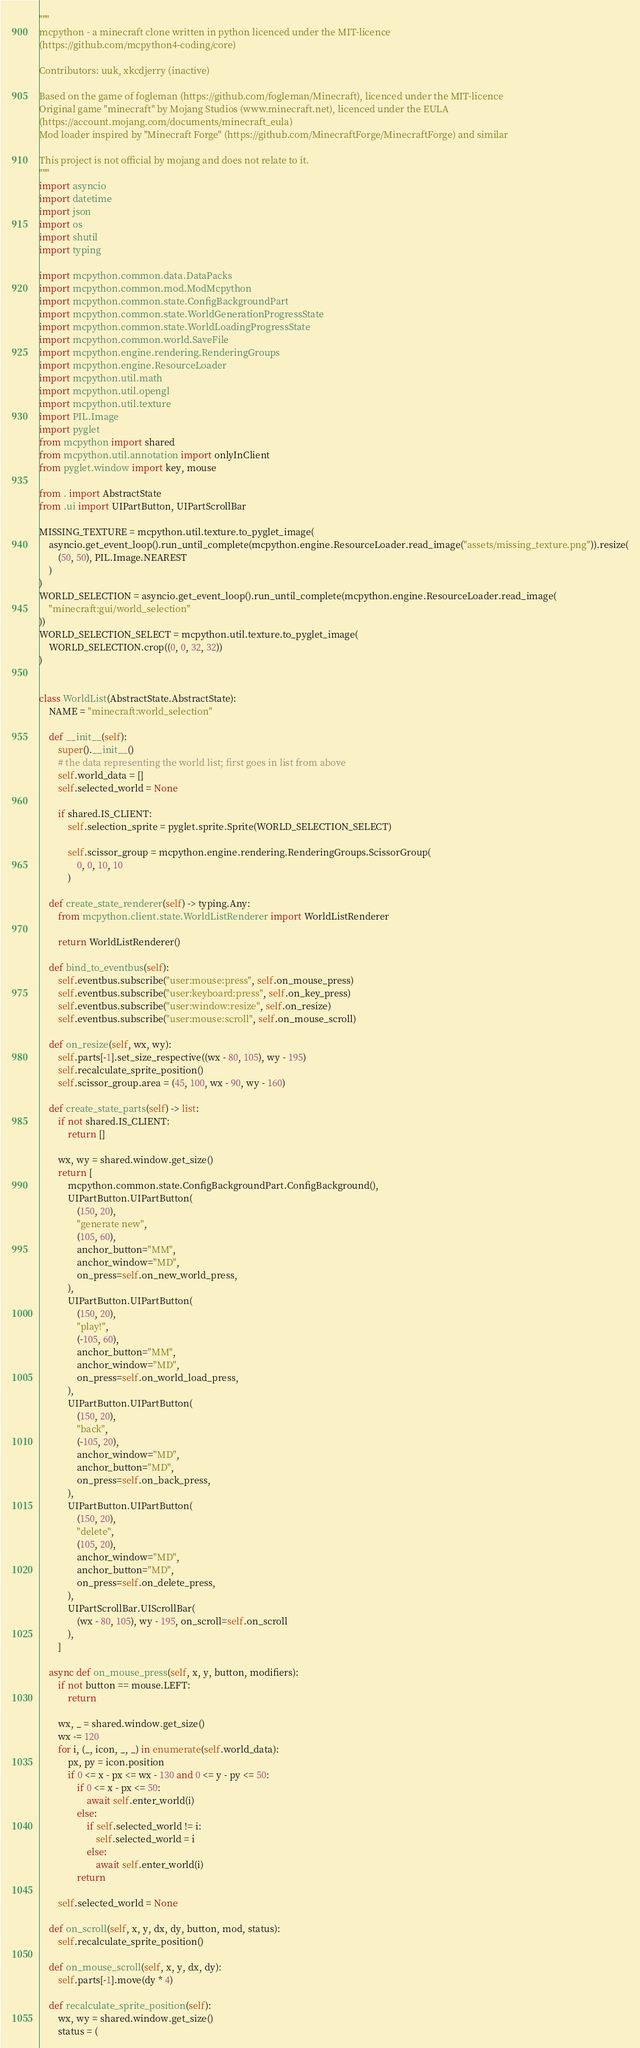<code> <loc_0><loc_0><loc_500><loc_500><_Python_>"""
mcpython - a minecraft clone written in python licenced under the MIT-licence 
(https://github.com/mcpython4-coding/core)

Contributors: uuk, xkcdjerry (inactive)

Based on the game of fogleman (https://github.com/fogleman/Minecraft), licenced under the MIT-licence
Original game "minecraft" by Mojang Studios (www.minecraft.net), licenced under the EULA
(https://account.mojang.com/documents/minecraft_eula)
Mod loader inspired by "Minecraft Forge" (https://github.com/MinecraftForge/MinecraftForge) and similar

This project is not official by mojang and does not relate to it.
"""
import asyncio
import datetime
import json
import os
import shutil
import typing

import mcpython.common.data.DataPacks
import mcpython.common.mod.ModMcpython
import mcpython.common.state.ConfigBackgroundPart
import mcpython.common.state.WorldGenerationProgressState
import mcpython.common.state.WorldLoadingProgressState
import mcpython.common.world.SaveFile
import mcpython.engine.rendering.RenderingGroups
import mcpython.engine.ResourceLoader
import mcpython.util.math
import mcpython.util.opengl
import mcpython.util.texture
import PIL.Image
import pyglet
from mcpython import shared
from mcpython.util.annotation import onlyInClient
from pyglet.window import key, mouse

from . import AbstractState
from .ui import UIPartButton, UIPartScrollBar

MISSING_TEXTURE = mcpython.util.texture.to_pyglet_image(
    asyncio.get_event_loop().run_until_complete(mcpython.engine.ResourceLoader.read_image("assets/missing_texture.png")).resize(
        (50, 50), PIL.Image.NEAREST
    )
)
WORLD_SELECTION = asyncio.get_event_loop().run_until_complete(mcpython.engine.ResourceLoader.read_image(
    "minecraft:gui/world_selection"
))
WORLD_SELECTION_SELECT = mcpython.util.texture.to_pyglet_image(
    WORLD_SELECTION.crop((0, 0, 32, 32))
)


class WorldList(AbstractState.AbstractState):
    NAME = "minecraft:world_selection"

    def __init__(self):
        super().__init__()
        # the data representing the world list; first goes in list from above
        self.world_data = []
        self.selected_world = None

        if shared.IS_CLIENT:
            self.selection_sprite = pyglet.sprite.Sprite(WORLD_SELECTION_SELECT)

            self.scissor_group = mcpython.engine.rendering.RenderingGroups.ScissorGroup(
                0, 0, 10, 10
            )

    def create_state_renderer(self) -> typing.Any:
        from mcpython.client.state.WorldListRenderer import WorldListRenderer

        return WorldListRenderer()

    def bind_to_eventbus(self):
        self.eventbus.subscribe("user:mouse:press", self.on_mouse_press)
        self.eventbus.subscribe("user:keyboard:press", self.on_key_press)
        self.eventbus.subscribe("user:window:resize", self.on_resize)
        self.eventbus.subscribe("user:mouse:scroll", self.on_mouse_scroll)

    def on_resize(self, wx, wy):
        self.parts[-1].set_size_respective((wx - 80, 105), wy - 195)
        self.recalculate_sprite_position()
        self.scissor_group.area = (45, 100, wx - 90, wy - 160)

    def create_state_parts(self) -> list:
        if not shared.IS_CLIENT:
            return []

        wx, wy = shared.window.get_size()
        return [
            mcpython.common.state.ConfigBackgroundPart.ConfigBackground(),
            UIPartButton.UIPartButton(
                (150, 20),
                "generate new",
                (105, 60),
                anchor_button="MM",
                anchor_window="MD",
                on_press=self.on_new_world_press,
            ),
            UIPartButton.UIPartButton(
                (150, 20),
                "play!",
                (-105, 60),
                anchor_button="MM",
                anchor_window="MD",
                on_press=self.on_world_load_press,
            ),
            UIPartButton.UIPartButton(
                (150, 20),
                "back",
                (-105, 20),
                anchor_window="MD",
                anchor_button="MD",
                on_press=self.on_back_press,
            ),
            UIPartButton.UIPartButton(
                (150, 20),
                "delete",
                (105, 20),
                anchor_window="MD",
                anchor_button="MD",
                on_press=self.on_delete_press,
            ),
            UIPartScrollBar.UIScrollBar(
                (wx - 80, 105), wy - 195, on_scroll=self.on_scroll
            ),
        ]

    async def on_mouse_press(self, x, y, button, modifiers):
        if not button == mouse.LEFT:
            return

        wx, _ = shared.window.get_size()
        wx -= 120
        for i, (_, icon, _, _) in enumerate(self.world_data):
            px, py = icon.position
            if 0 <= x - px <= wx - 130 and 0 <= y - py <= 50:
                if 0 <= x - px <= 50:
                    await self.enter_world(i)
                else:
                    if self.selected_world != i:
                        self.selected_world = i
                    else:
                        await self.enter_world(i)
                return

        self.selected_world = None

    def on_scroll(self, x, y, dx, dy, button, mod, status):
        self.recalculate_sprite_position()

    def on_mouse_scroll(self, x, y, dx, dy):
        self.parts[-1].move(dy * 4)

    def recalculate_sprite_position(self):
        wx, wy = shared.window.get_size()
        status = (</code> 